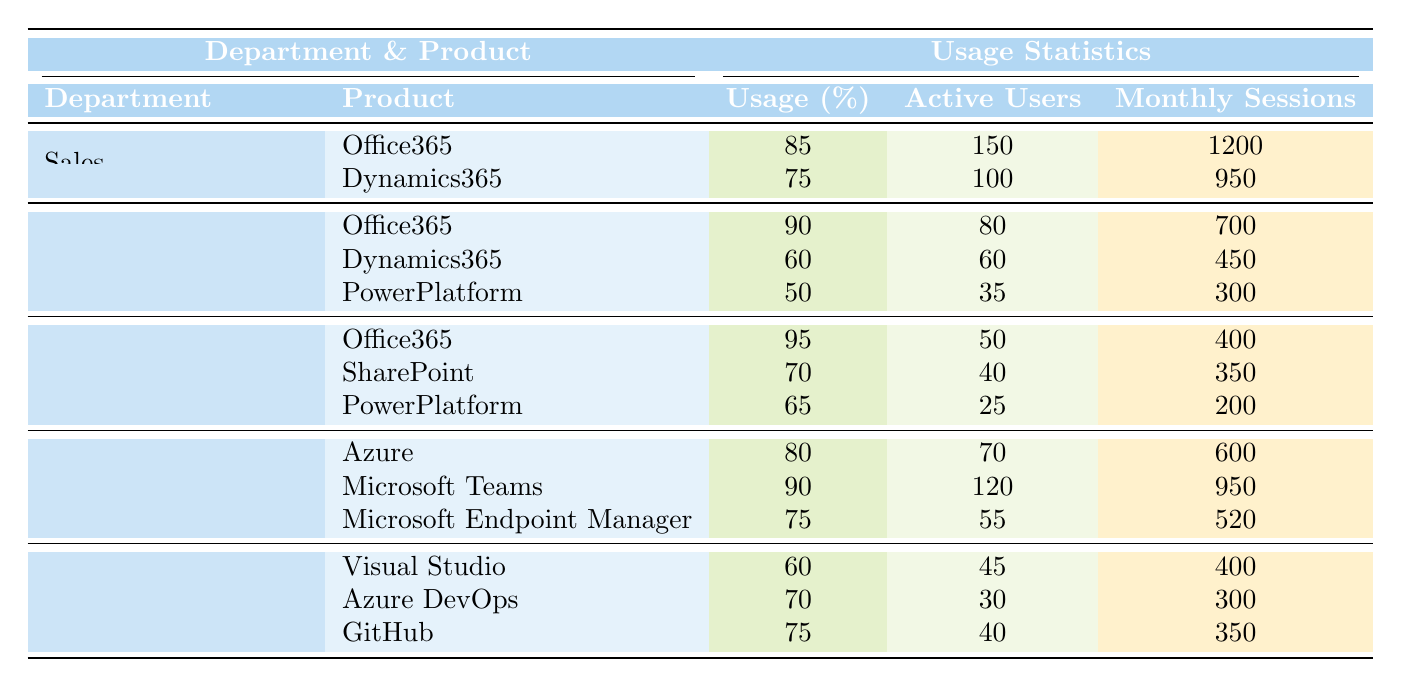What is the usage percentage of Office365 in the Human Resources department? The usage percentage of Office365 in the Human Resources department is clearly listed in the table as 95%.
Answer: 95% Which department has the highest number of active users for Microsoft Teams? The IT department is listed as having 120 active users for Microsoft Teams, which is the highest among all departments for this product.
Answer: IT department How many monthly sessions does Dynamics365 have in Marketing? The table indicates that Dynamics365 in the Marketing department has 450 monthly sessions.
Answer: 450 What is the average usage percentage of PowerPlatform across all departments? The usage percentages for PowerPlatform in the departments that use it are: 50% (Marketing), 65% (Human Resources). Sum them: 50 + 65 = 115. There are 2 departments, so the average is 115 / 2 = 57.5%.
Answer: 57.5% Is the usage percentage of Azure higher than that of GitHub in the Product Development department? Azure has a usage percentage of 80%, while GitHub has a usage percentage of 75%. Since 80% is greater than 75%, the statement is true.
Answer: Yes What is the total number of active users for Office365 across all departments? Counting the active users for Office365: Sales (150) + Marketing (80) + Human Resources (50) + IT (not applicable for Office365, so 0). Total = 150 + 80 + 50 = 280.
Answer: 280 Which department has the lowest monthly sessions for its products? The PowerPlatform in Human Resources has the lowest monthly sessions at 200, which is the least when compared to other departments and their respective products.
Answer: Human Resources If you combine the active users of Visual Studio and Azure DevOps, how many users do you have? The active users for Visual Studio are 45 and for Azure DevOps are 30. Adding them gives 45 + 30 = 75 active users total.
Answer: 75 What is the highest usage percentage recorded in the table? The highest usage percentage recorded in the table is 95% for Office365 in the Human Resources department.
Answer: 95% Does the Marketing department have more active users for Office365 than for Dynamics365? Yes, the Marketing department has 80 active users for Office365 and only 60 for Dynamics365, which indicates that there are more users for Office365.
Answer: Yes 